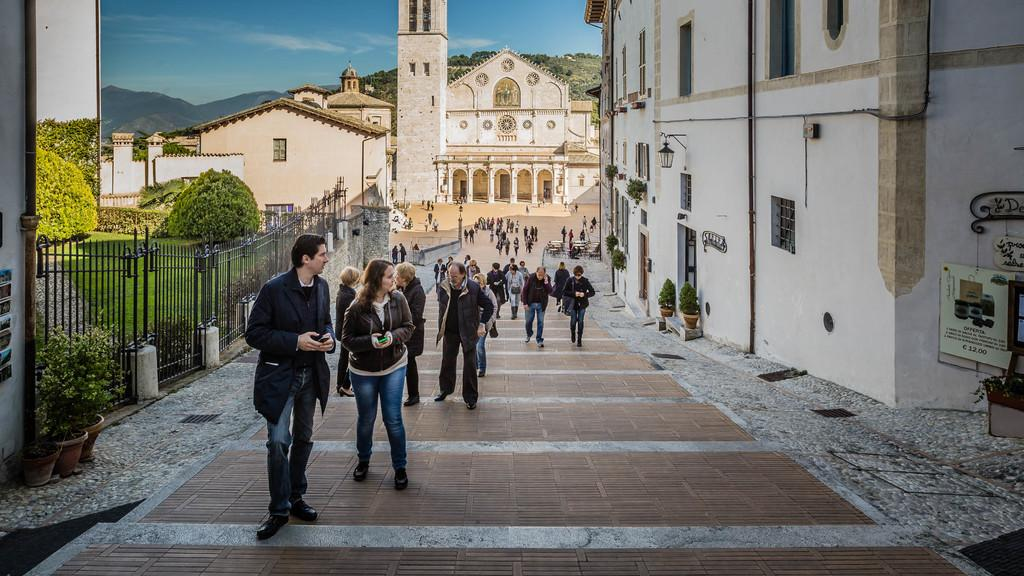What are the people in the image doing? The people in the image are walking on the floor. What can be seen on the right side of the image? There are buildings on the right side of the image. What is located on the left side of the image? There is an iron grill on the left side of the image. What is visible at the top of the image? The sky is visible at the top of the image. What type of instrument is being played by the people in the image? There is no instrument being played in the image; the people are simply walking. Can you describe the brass elements in the image? There are no brass elements present in the image. 